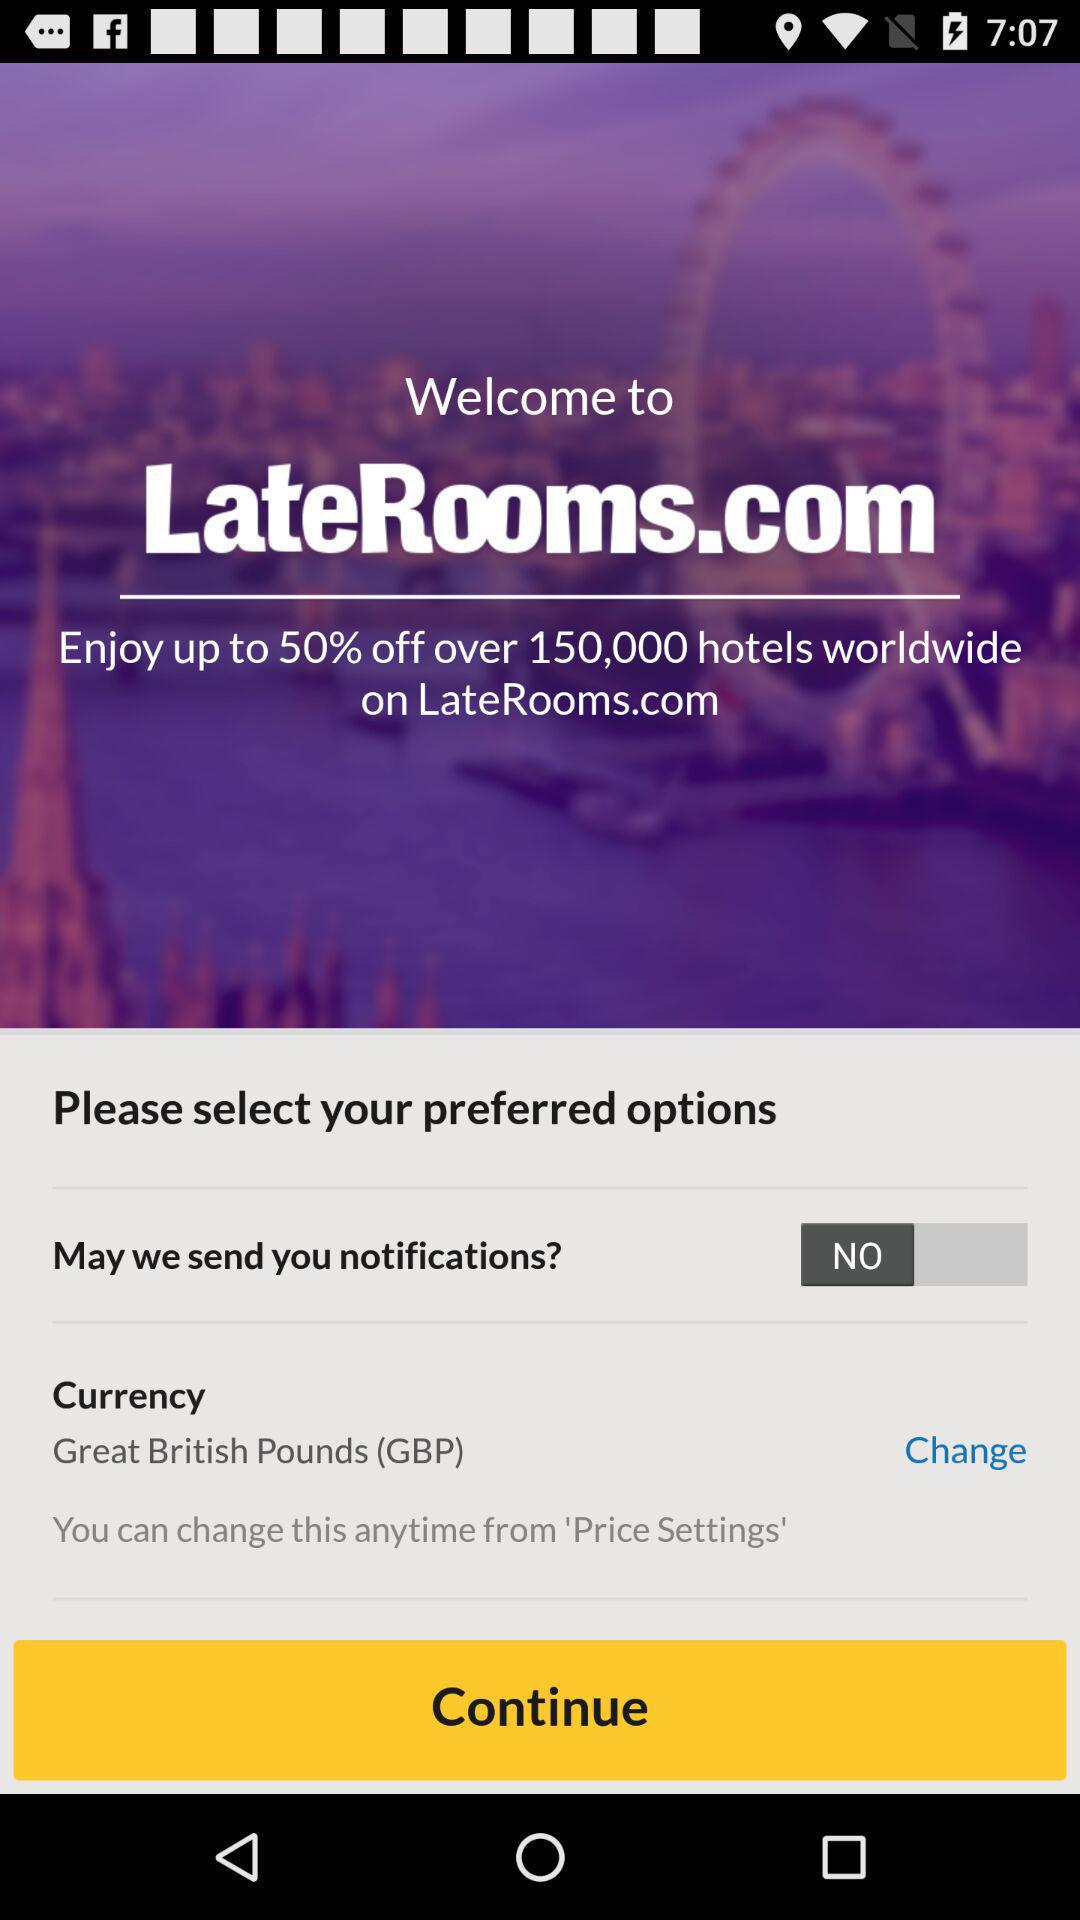What is the selected currency? The selected currency is Great British Pounds (GBP). 